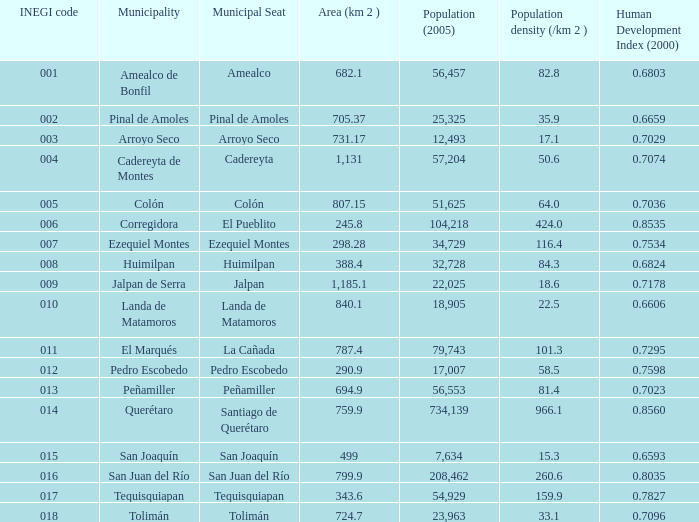In which territory (km 2) is the population (2005) 57,204 and the human development index (2000) under 0.0. 